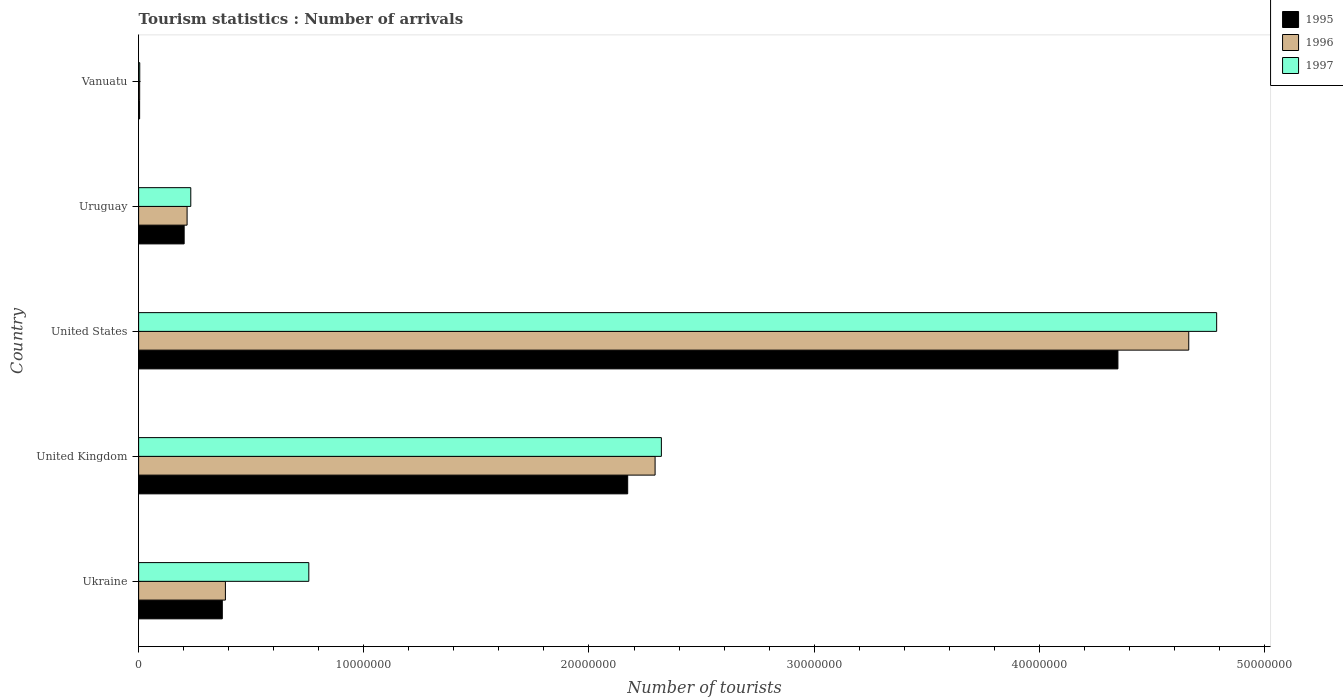How many different coloured bars are there?
Provide a short and direct response. 3. Are the number of bars per tick equal to the number of legend labels?
Offer a terse response. Yes. How many bars are there on the 2nd tick from the top?
Keep it short and to the point. 3. How many bars are there on the 1st tick from the bottom?
Make the answer very short. 3. In how many cases, is the number of bars for a given country not equal to the number of legend labels?
Keep it short and to the point. 0. Across all countries, what is the maximum number of tourist arrivals in 1997?
Your response must be concise. 4.79e+07. Across all countries, what is the minimum number of tourist arrivals in 1995?
Provide a short and direct response. 4.40e+04. In which country was the number of tourist arrivals in 1997 minimum?
Your response must be concise. Vanuatu. What is the total number of tourist arrivals in 1997 in the graph?
Make the answer very short. 8.10e+07. What is the difference between the number of tourist arrivals in 1997 in Ukraine and that in United Kingdom?
Give a very brief answer. -1.57e+07. What is the difference between the number of tourist arrivals in 1996 in Uruguay and the number of tourist arrivals in 1995 in Vanuatu?
Your response must be concise. 2.11e+06. What is the average number of tourist arrivals in 1995 per country?
Offer a very short reply. 1.42e+07. What is the difference between the number of tourist arrivals in 1997 and number of tourist arrivals in 1995 in United Kingdom?
Give a very brief answer. 1.50e+06. What is the ratio of the number of tourist arrivals in 1995 in Ukraine to that in Uruguay?
Ensure brevity in your answer.  1.84. Is the number of tourist arrivals in 1996 in Ukraine less than that in Vanuatu?
Give a very brief answer. No. What is the difference between the highest and the second highest number of tourist arrivals in 1996?
Your answer should be very brief. 2.37e+07. What is the difference between the highest and the lowest number of tourist arrivals in 1995?
Provide a succinct answer. 4.34e+07. Is the sum of the number of tourist arrivals in 1997 in Ukraine and United Kingdom greater than the maximum number of tourist arrivals in 1996 across all countries?
Your answer should be very brief. No. What does the 3rd bar from the top in Ukraine represents?
Offer a very short reply. 1995. Is it the case that in every country, the sum of the number of tourist arrivals in 1996 and number of tourist arrivals in 1997 is greater than the number of tourist arrivals in 1995?
Your response must be concise. Yes. Are all the bars in the graph horizontal?
Offer a very short reply. Yes. Does the graph contain any zero values?
Offer a terse response. No. Where does the legend appear in the graph?
Your answer should be very brief. Top right. What is the title of the graph?
Provide a short and direct response. Tourism statistics : Number of arrivals. What is the label or title of the X-axis?
Give a very brief answer. Number of tourists. What is the Number of tourists of 1995 in Ukraine?
Your answer should be compact. 3.72e+06. What is the Number of tourists in 1996 in Ukraine?
Your response must be concise. 3.85e+06. What is the Number of tourists in 1997 in Ukraine?
Keep it short and to the point. 7.56e+06. What is the Number of tourists in 1995 in United Kingdom?
Your answer should be very brief. 2.17e+07. What is the Number of tourists of 1996 in United Kingdom?
Give a very brief answer. 2.29e+07. What is the Number of tourists in 1997 in United Kingdom?
Your response must be concise. 2.32e+07. What is the Number of tourists of 1995 in United States?
Give a very brief answer. 4.35e+07. What is the Number of tourists in 1996 in United States?
Your response must be concise. 4.66e+07. What is the Number of tourists in 1997 in United States?
Give a very brief answer. 4.79e+07. What is the Number of tourists in 1995 in Uruguay?
Offer a very short reply. 2.02e+06. What is the Number of tourists of 1996 in Uruguay?
Your response must be concise. 2.15e+06. What is the Number of tourists in 1997 in Uruguay?
Your answer should be compact. 2.32e+06. What is the Number of tourists of 1995 in Vanuatu?
Your answer should be compact. 4.40e+04. What is the Number of tourists in 1996 in Vanuatu?
Your response must be concise. 4.60e+04. Across all countries, what is the maximum Number of tourists of 1995?
Offer a terse response. 4.35e+07. Across all countries, what is the maximum Number of tourists of 1996?
Provide a short and direct response. 4.66e+07. Across all countries, what is the maximum Number of tourists in 1997?
Offer a terse response. 4.79e+07. Across all countries, what is the minimum Number of tourists of 1995?
Make the answer very short. 4.40e+04. Across all countries, what is the minimum Number of tourists in 1996?
Ensure brevity in your answer.  4.60e+04. Across all countries, what is the minimum Number of tourists in 1997?
Offer a terse response. 5.00e+04. What is the total Number of tourists of 1995 in the graph?
Keep it short and to the point. 7.10e+07. What is the total Number of tourists in 1996 in the graph?
Keep it short and to the point. 7.56e+07. What is the total Number of tourists in 1997 in the graph?
Offer a very short reply. 8.10e+07. What is the difference between the Number of tourists of 1995 in Ukraine and that in United Kingdom?
Your answer should be very brief. -1.80e+07. What is the difference between the Number of tourists of 1996 in Ukraine and that in United Kingdom?
Make the answer very short. -1.91e+07. What is the difference between the Number of tourists in 1997 in Ukraine and that in United Kingdom?
Your response must be concise. -1.57e+07. What is the difference between the Number of tourists of 1995 in Ukraine and that in United States?
Make the answer very short. -3.98e+07. What is the difference between the Number of tourists of 1996 in Ukraine and that in United States?
Provide a succinct answer. -4.28e+07. What is the difference between the Number of tourists in 1997 in Ukraine and that in United States?
Keep it short and to the point. -4.03e+07. What is the difference between the Number of tourists of 1995 in Ukraine and that in Uruguay?
Your answer should be compact. 1.69e+06. What is the difference between the Number of tourists in 1996 in Ukraine and that in Uruguay?
Give a very brief answer. 1.70e+06. What is the difference between the Number of tourists of 1997 in Ukraine and that in Uruguay?
Offer a very short reply. 5.24e+06. What is the difference between the Number of tourists of 1995 in Ukraine and that in Vanuatu?
Make the answer very short. 3.67e+06. What is the difference between the Number of tourists of 1996 in Ukraine and that in Vanuatu?
Make the answer very short. 3.81e+06. What is the difference between the Number of tourists of 1997 in Ukraine and that in Vanuatu?
Offer a very short reply. 7.51e+06. What is the difference between the Number of tourists of 1995 in United Kingdom and that in United States?
Provide a short and direct response. -2.18e+07. What is the difference between the Number of tourists of 1996 in United Kingdom and that in United States?
Provide a short and direct response. -2.37e+07. What is the difference between the Number of tourists in 1997 in United Kingdom and that in United States?
Ensure brevity in your answer.  -2.47e+07. What is the difference between the Number of tourists in 1995 in United Kingdom and that in Uruguay?
Offer a terse response. 1.97e+07. What is the difference between the Number of tourists in 1996 in United Kingdom and that in Uruguay?
Provide a short and direct response. 2.08e+07. What is the difference between the Number of tourists in 1997 in United Kingdom and that in Uruguay?
Your response must be concise. 2.09e+07. What is the difference between the Number of tourists in 1995 in United Kingdom and that in Vanuatu?
Offer a very short reply. 2.17e+07. What is the difference between the Number of tourists of 1996 in United Kingdom and that in Vanuatu?
Ensure brevity in your answer.  2.29e+07. What is the difference between the Number of tourists of 1997 in United Kingdom and that in Vanuatu?
Ensure brevity in your answer.  2.32e+07. What is the difference between the Number of tourists in 1995 in United States and that in Uruguay?
Offer a terse response. 4.15e+07. What is the difference between the Number of tourists in 1996 in United States and that in Uruguay?
Make the answer very short. 4.45e+07. What is the difference between the Number of tourists of 1997 in United States and that in Uruguay?
Give a very brief answer. 4.56e+07. What is the difference between the Number of tourists of 1995 in United States and that in Vanuatu?
Offer a very short reply. 4.34e+07. What is the difference between the Number of tourists in 1996 in United States and that in Vanuatu?
Your answer should be compact. 4.66e+07. What is the difference between the Number of tourists in 1997 in United States and that in Vanuatu?
Make the answer very short. 4.78e+07. What is the difference between the Number of tourists in 1995 in Uruguay and that in Vanuatu?
Keep it short and to the point. 1.98e+06. What is the difference between the Number of tourists in 1996 in Uruguay and that in Vanuatu?
Offer a terse response. 2.11e+06. What is the difference between the Number of tourists in 1997 in Uruguay and that in Vanuatu?
Provide a short and direct response. 2.27e+06. What is the difference between the Number of tourists of 1995 in Ukraine and the Number of tourists of 1996 in United Kingdom?
Your answer should be very brief. -1.92e+07. What is the difference between the Number of tourists in 1995 in Ukraine and the Number of tourists in 1997 in United Kingdom?
Your answer should be very brief. -1.95e+07. What is the difference between the Number of tourists of 1996 in Ukraine and the Number of tourists of 1997 in United Kingdom?
Give a very brief answer. -1.94e+07. What is the difference between the Number of tourists of 1995 in Ukraine and the Number of tourists of 1996 in United States?
Your answer should be compact. -4.29e+07. What is the difference between the Number of tourists in 1995 in Ukraine and the Number of tourists in 1997 in United States?
Give a very brief answer. -4.42e+07. What is the difference between the Number of tourists in 1996 in Ukraine and the Number of tourists in 1997 in United States?
Make the answer very short. -4.40e+07. What is the difference between the Number of tourists of 1995 in Ukraine and the Number of tourists of 1996 in Uruguay?
Ensure brevity in your answer.  1.56e+06. What is the difference between the Number of tourists of 1995 in Ukraine and the Number of tourists of 1997 in Uruguay?
Ensure brevity in your answer.  1.40e+06. What is the difference between the Number of tourists of 1996 in Ukraine and the Number of tourists of 1997 in Uruguay?
Offer a very short reply. 1.54e+06. What is the difference between the Number of tourists of 1995 in Ukraine and the Number of tourists of 1996 in Vanuatu?
Make the answer very short. 3.67e+06. What is the difference between the Number of tourists of 1995 in Ukraine and the Number of tourists of 1997 in Vanuatu?
Provide a succinct answer. 3.67e+06. What is the difference between the Number of tourists in 1996 in Ukraine and the Number of tourists in 1997 in Vanuatu?
Your answer should be very brief. 3.80e+06. What is the difference between the Number of tourists of 1995 in United Kingdom and the Number of tourists of 1996 in United States?
Make the answer very short. -2.49e+07. What is the difference between the Number of tourists of 1995 in United Kingdom and the Number of tourists of 1997 in United States?
Provide a short and direct response. -2.62e+07. What is the difference between the Number of tourists of 1996 in United Kingdom and the Number of tourists of 1997 in United States?
Make the answer very short. -2.49e+07. What is the difference between the Number of tourists of 1995 in United Kingdom and the Number of tourists of 1996 in Uruguay?
Offer a very short reply. 1.96e+07. What is the difference between the Number of tourists in 1995 in United Kingdom and the Number of tourists in 1997 in Uruguay?
Make the answer very short. 1.94e+07. What is the difference between the Number of tourists in 1996 in United Kingdom and the Number of tourists in 1997 in Uruguay?
Offer a terse response. 2.06e+07. What is the difference between the Number of tourists in 1995 in United Kingdom and the Number of tourists in 1996 in Vanuatu?
Keep it short and to the point. 2.17e+07. What is the difference between the Number of tourists of 1995 in United Kingdom and the Number of tourists of 1997 in Vanuatu?
Provide a succinct answer. 2.17e+07. What is the difference between the Number of tourists of 1996 in United Kingdom and the Number of tourists of 1997 in Vanuatu?
Give a very brief answer. 2.29e+07. What is the difference between the Number of tourists in 1995 in United States and the Number of tourists in 1996 in Uruguay?
Provide a succinct answer. 4.13e+07. What is the difference between the Number of tourists in 1995 in United States and the Number of tourists in 1997 in Uruguay?
Provide a short and direct response. 4.12e+07. What is the difference between the Number of tourists of 1996 in United States and the Number of tourists of 1997 in Uruguay?
Provide a short and direct response. 4.43e+07. What is the difference between the Number of tourists of 1995 in United States and the Number of tourists of 1996 in Vanuatu?
Offer a terse response. 4.34e+07. What is the difference between the Number of tourists in 1995 in United States and the Number of tourists in 1997 in Vanuatu?
Provide a short and direct response. 4.34e+07. What is the difference between the Number of tourists in 1996 in United States and the Number of tourists in 1997 in Vanuatu?
Provide a short and direct response. 4.66e+07. What is the difference between the Number of tourists in 1995 in Uruguay and the Number of tourists in 1996 in Vanuatu?
Your answer should be compact. 1.98e+06. What is the difference between the Number of tourists of 1995 in Uruguay and the Number of tourists of 1997 in Vanuatu?
Your answer should be compact. 1.97e+06. What is the difference between the Number of tourists in 1996 in Uruguay and the Number of tourists in 1997 in Vanuatu?
Provide a short and direct response. 2.10e+06. What is the average Number of tourists of 1995 per country?
Your answer should be compact. 1.42e+07. What is the average Number of tourists in 1996 per country?
Your answer should be compact. 1.51e+07. What is the average Number of tourists in 1997 per country?
Provide a succinct answer. 1.62e+07. What is the difference between the Number of tourists of 1995 and Number of tourists of 1996 in Ukraine?
Make the answer very short. -1.38e+05. What is the difference between the Number of tourists in 1995 and Number of tourists in 1997 in Ukraine?
Provide a succinct answer. -3.84e+06. What is the difference between the Number of tourists of 1996 and Number of tourists of 1997 in Ukraine?
Provide a short and direct response. -3.70e+06. What is the difference between the Number of tourists in 1995 and Number of tourists in 1996 in United Kingdom?
Make the answer very short. -1.22e+06. What is the difference between the Number of tourists of 1995 and Number of tourists of 1997 in United Kingdom?
Make the answer very short. -1.50e+06. What is the difference between the Number of tourists in 1996 and Number of tourists in 1997 in United Kingdom?
Make the answer very short. -2.79e+05. What is the difference between the Number of tourists in 1995 and Number of tourists in 1996 in United States?
Make the answer very short. -3.15e+06. What is the difference between the Number of tourists of 1995 and Number of tourists of 1997 in United States?
Give a very brief answer. -4.38e+06. What is the difference between the Number of tourists of 1996 and Number of tourists of 1997 in United States?
Make the answer very short. -1.24e+06. What is the difference between the Number of tourists in 1995 and Number of tourists in 1997 in Uruguay?
Your answer should be compact. -2.94e+05. What is the difference between the Number of tourists of 1996 and Number of tourists of 1997 in Uruguay?
Provide a succinct answer. -1.64e+05. What is the difference between the Number of tourists in 1995 and Number of tourists in 1996 in Vanuatu?
Make the answer very short. -2000. What is the difference between the Number of tourists in 1995 and Number of tourists in 1997 in Vanuatu?
Ensure brevity in your answer.  -6000. What is the difference between the Number of tourists of 1996 and Number of tourists of 1997 in Vanuatu?
Provide a succinct answer. -4000. What is the ratio of the Number of tourists of 1995 in Ukraine to that in United Kingdom?
Your response must be concise. 0.17. What is the ratio of the Number of tourists of 1996 in Ukraine to that in United Kingdom?
Keep it short and to the point. 0.17. What is the ratio of the Number of tourists in 1997 in Ukraine to that in United Kingdom?
Give a very brief answer. 0.33. What is the ratio of the Number of tourists of 1995 in Ukraine to that in United States?
Keep it short and to the point. 0.09. What is the ratio of the Number of tourists in 1996 in Ukraine to that in United States?
Keep it short and to the point. 0.08. What is the ratio of the Number of tourists in 1997 in Ukraine to that in United States?
Offer a very short reply. 0.16. What is the ratio of the Number of tourists in 1995 in Ukraine to that in Uruguay?
Provide a short and direct response. 1.84. What is the ratio of the Number of tourists of 1996 in Ukraine to that in Uruguay?
Offer a terse response. 1.79. What is the ratio of the Number of tourists in 1997 in Ukraine to that in Uruguay?
Keep it short and to the point. 3.26. What is the ratio of the Number of tourists in 1995 in Ukraine to that in Vanuatu?
Ensure brevity in your answer.  84.45. What is the ratio of the Number of tourists in 1996 in Ukraine to that in Vanuatu?
Provide a short and direct response. 83.78. What is the ratio of the Number of tourists in 1997 in Ukraine to that in Vanuatu?
Give a very brief answer. 151.16. What is the ratio of the Number of tourists in 1995 in United Kingdom to that in United States?
Provide a short and direct response. 0.5. What is the ratio of the Number of tourists in 1996 in United Kingdom to that in United States?
Your answer should be very brief. 0.49. What is the ratio of the Number of tourists of 1997 in United Kingdom to that in United States?
Ensure brevity in your answer.  0.48. What is the ratio of the Number of tourists of 1995 in United Kingdom to that in Uruguay?
Your response must be concise. 10.74. What is the ratio of the Number of tourists of 1996 in United Kingdom to that in Uruguay?
Provide a short and direct response. 10.66. What is the ratio of the Number of tourists of 1997 in United Kingdom to that in Uruguay?
Your response must be concise. 10.02. What is the ratio of the Number of tourists of 1995 in United Kingdom to that in Vanuatu?
Offer a terse response. 493.61. What is the ratio of the Number of tourists of 1996 in United Kingdom to that in Vanuatu?
Your answer should be very brief. 498.61. What is the ratio of the Number of tourists in 1997 in United Kingdom to that in Vanuatu?
Offer a very short reply. 464.3. What is the ratio of the Number of tourists of 1995 in United States to that in Uruguay?
Make the answer very short. 21.51. What is the ratio of the Number of tourists of 1996 in United States to that in Uruguay?
Offer a terse response. 21.67. What is the ratio of the Number of tourists of 1997 in United States to that in Uruguay?
Your answer should be compact. 20.67. What is the ratio of the Number of tourists in 1995 in United States to that in Vanuatu?
Make the answer very short. 988.41. What is the ratio of the Number of tourists of 1996 in United States to that in Vanuatu?
Your response must be concise. 1013.83. What is the ratio of the Number of tourists in 1997 in United States to that in Vanuatu?
Make the answer very short. 957.5. What is the ratio of the Number of tourists in 1995 in Uruguay to that in Vanuatu?
Provide a succinct answer. 45.95. What is the ratio of the Number of tourists in 1996 in Uruguay to that in Vanuatu?
Give a very brief answer. 46.78. What is the ratio of the Number of tourists in 1997 in Uruguay to that in Vanuatu?
Provide a short and direct response. 46.32. What is the difference between the highest and the second highest Number of tourists of 1995?
Your response must be concise. 2.18e+07. What is the difference between the highest and the second highest Number of tourists of 1996?
Your answer should be compact. 2.37e+07. What is the difference between the highest and the second highest Number of tourists of 1997?
Offer a terse response. 2.47e+07. What is the difference between the highest and the lowest Number of tourists of 1995?
Offer a terse response. 4.34e+07. What is the difference between the highest and the lowest Number of tourists of 1996?
Offer a very short reply. 4.66e+07. What is the difference between the highest and the lowest Number of tourists of 1997?
Offer a very short reply. 4.78e+07. 